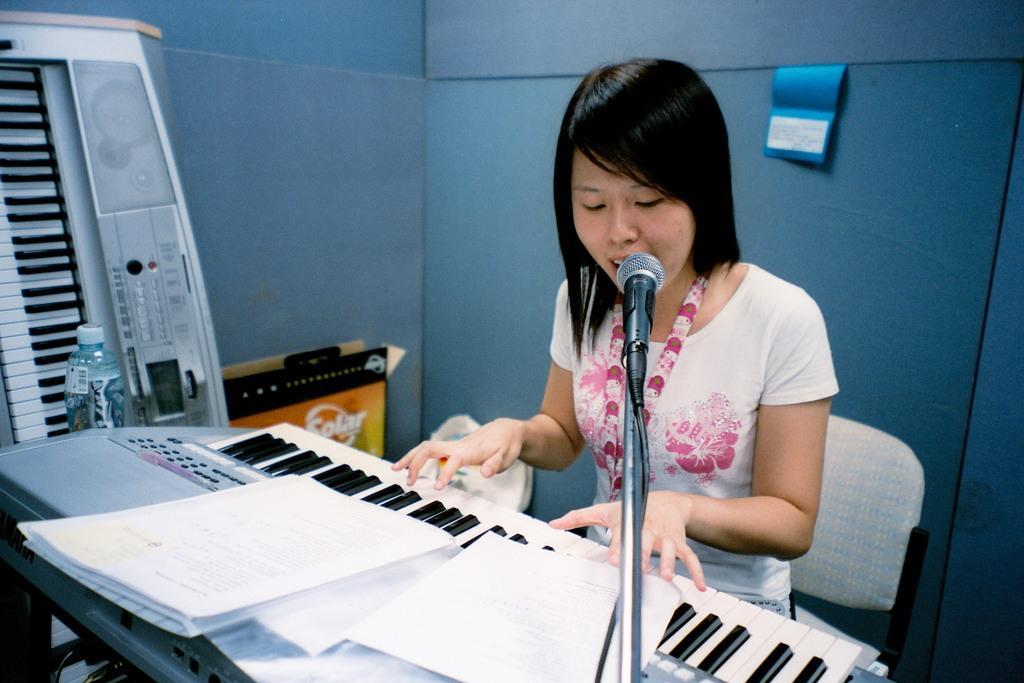How would you summarize this image in a sentence or two? In this image I can see the person with pink and white color dress. In-front of the person I can see the musical instrument and the mic. I can see few papers on the musical instrument. To the left I can see the bottle and an another musical instrument. I can see the blue background. 